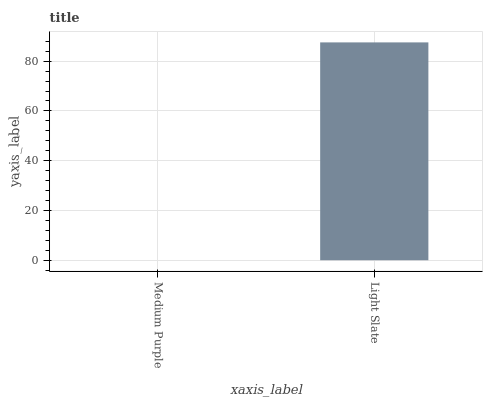Is Medium Purple the minimum?
Answer yes or no. Yes. Is Light Slate the maximum?
Answer yes or no. Yes. Is Light Slate the minimum?
Answer yes or no. No. Is Light Slate greater than Medium Purple?
Answer yes or no. Yes. Is Medium Purple less than Light Slate?
Answer yes or no. Yes. Is Medium Purple greater than Light Slate?
Answer yes or no. No. Is Light Slate less than Medium Purple?
Answer yes or no. No. Is Light Slate the high median?
Answer yes or no. Yes. Is Medium Purple the low median?
Answer yes or no. Yes. Is Medium Purple the high median?
Answer yes or no. No. Is Light Slate the low median?
Answer yes or no. No. 